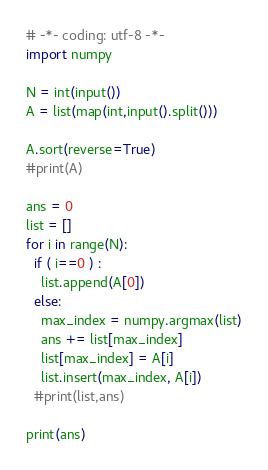<code> <loc_0><loc_0><loc_500><loc_500><_Python_># -*- coding: utf-8 -*-
import numpy

N = int(input())
A = list(map(int,input().split()))

A.sort(reverse=True)
#print(A)

ans = 0
list = []
for i in range(N):
  if ( i==0 ) :
    list.append(A[0])
  else:
    max_index = numpy.argmax(list)
    ans += list[max_index]
    list[max_index] = A[i]
    list.insert(max_index, A[i])
  #print(list,ans)

print(ans)</code> 